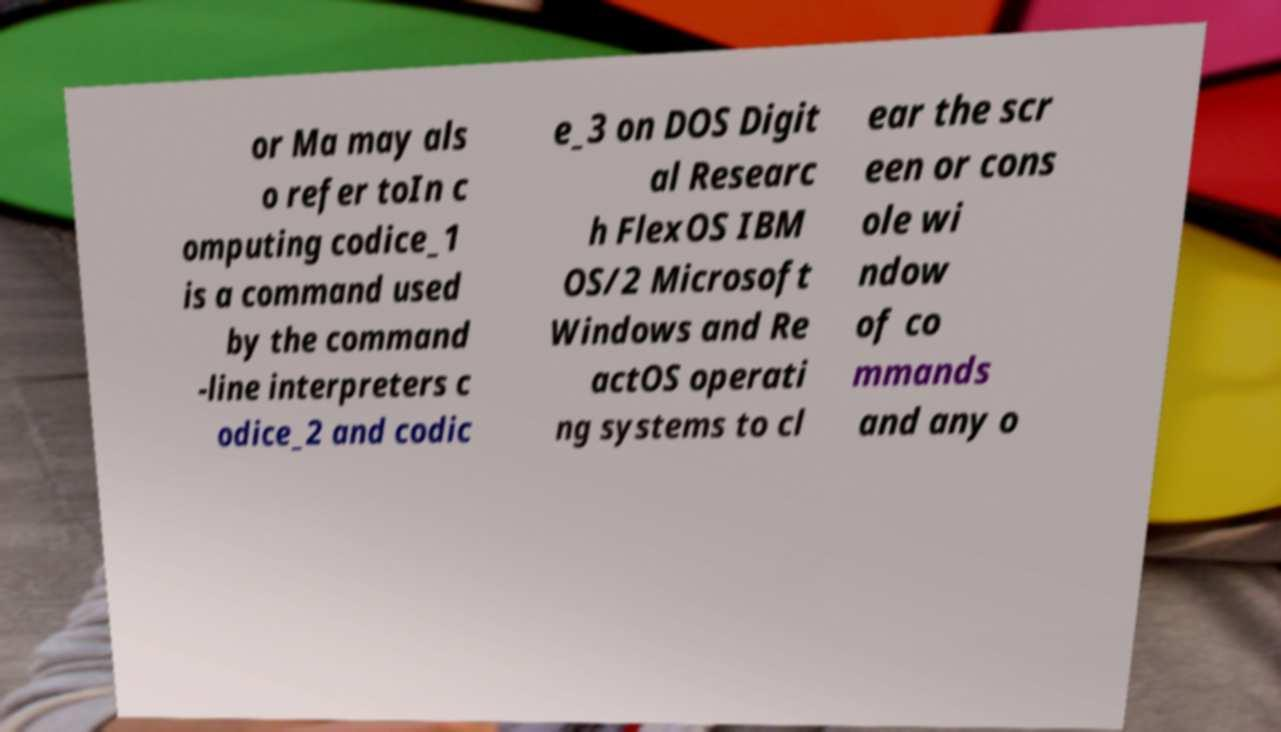Can you read and provide the text displayed in the image?This photo seems to have some interesting text. Can you extract and type it out for me? or Ma may als o refer toIn c omputing codice_1 is a command used by the command -line interpreters c odice_2 and codic e_3 on DOS Digit al Researc h FlexOS IBM OS/2 Microsoft Windows and Re actOS operati ng systems to cl ear the scr een or cons ole wi ndow of co mmands and any o 